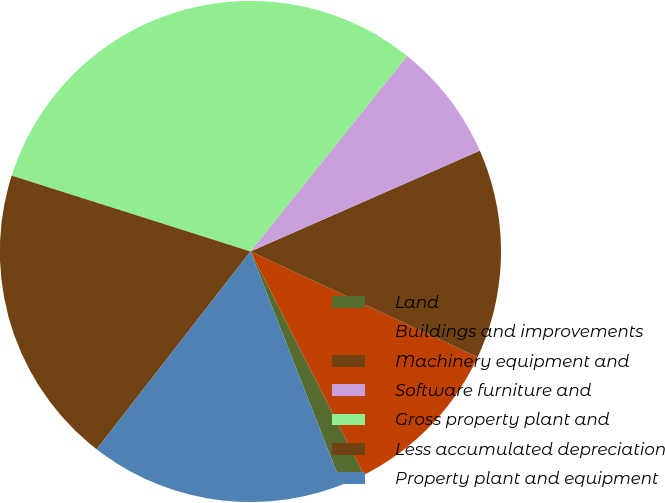<chart> <loc_0><loc_0><loc_500><loc_500><pie_chart><fcel>Land<fcel>Buildings and improvements<fcel>Machinery equipment and<fcel>Software furniture and<fcel>Gross property plant and<fcel>Less accumulated depreciation<fcel>Property plant and equipment<nl><fcel>1.55%<fcel>10.59%<fcel>13.52%<fcel>7.66%<fcel>30.86%<fcel>19.38%<fcel>16.45%<nl></chart> 